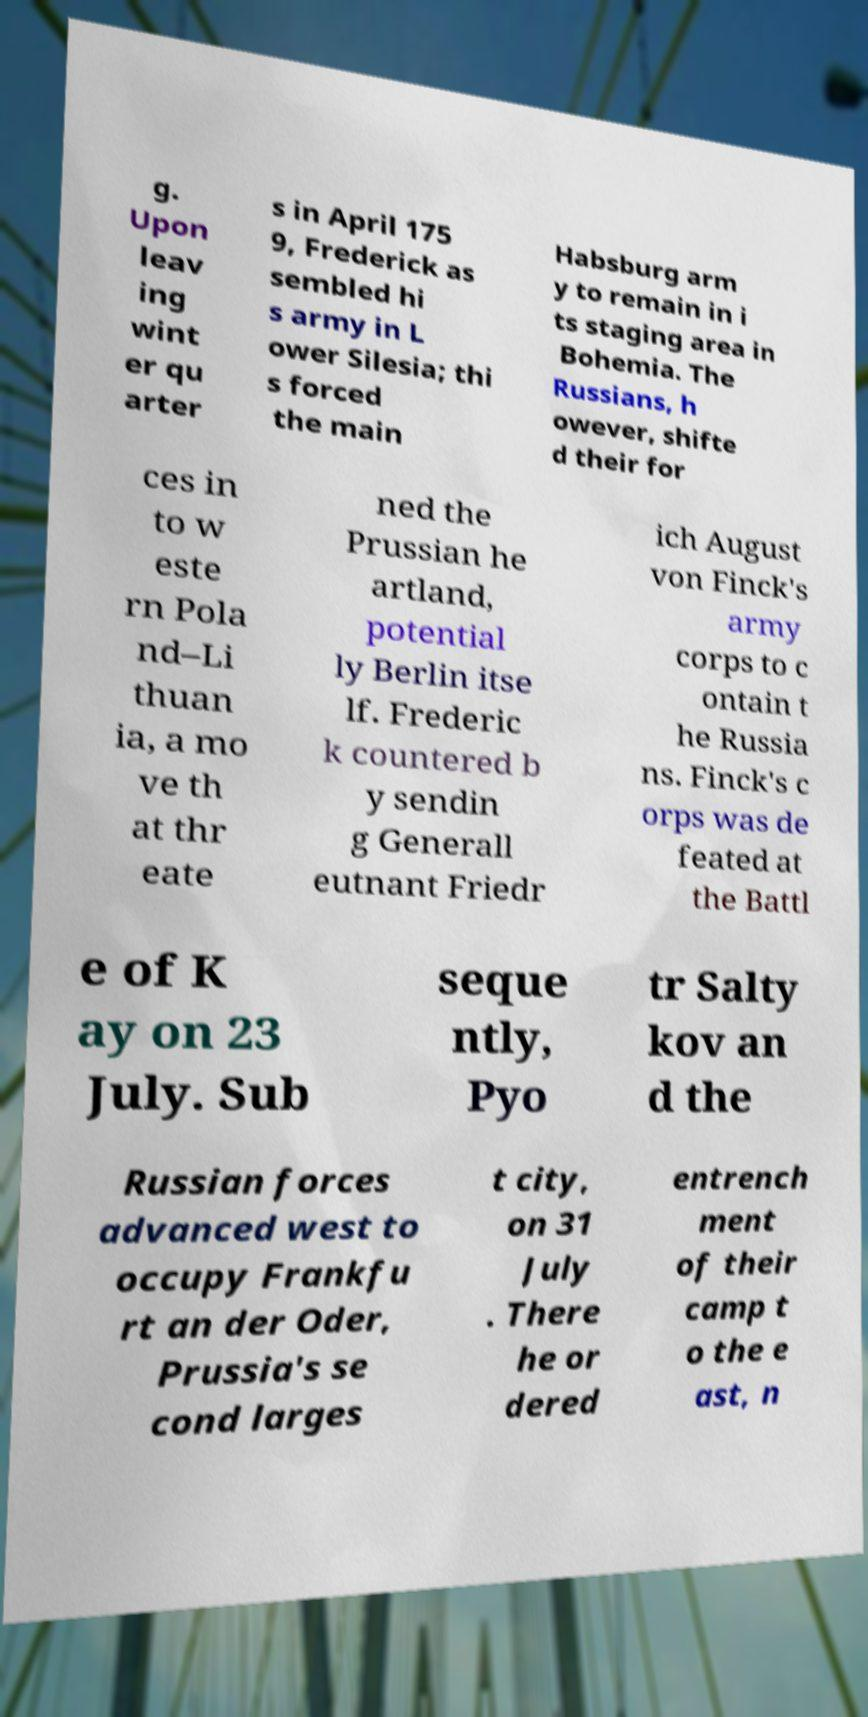Please read and relay the text visible in this image. What does it say? g. Upon leav ing wint er qu arter s in April 175 9, Frederick as sembled hi s army in L ower Silesia; thi s forced the main Habsburg arm y to remain in i ts staging area in Bohemia. The Russians, h owever, shifte d their for ces in to w este rn Pola nd–Li thuan ia, a mo ve th at thr eate ned the Prussian he artland, potential ly Berlin itse lf. Frederic k countered b y sendin g Generall eutnant Friedr ich August von Finck's army corps to c ontain t he Russia ns. Finck's c orps was de feated at the Battl e of K ay on 23 July. Sub seque ntly, Pyo tr Salty kov an d the Russian forces advanced west to occupy Frankfu rt an der Oder, Prussia's se cond larges t city, on 31 July . There he or dered entrench ment of their camp t o the e ast, n 